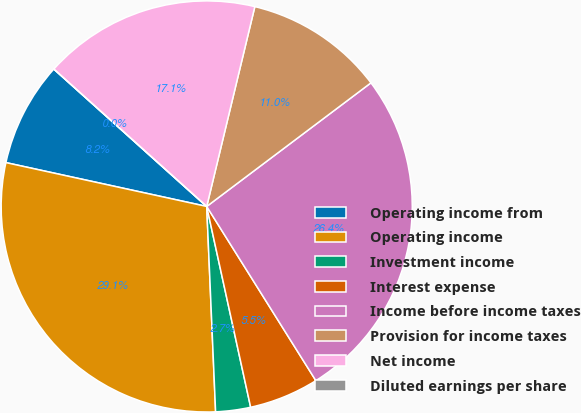Convert chart to OTSL. <chart><loc_0><loc_0><loc_500><loc_500><pie_chart><fcel>Operating income from<fcel>Operating income<fcel>Investment income<fcel>Interest expense<fcel>Income before income taxes<fcel>Provision for income taxes<fcel>Net income<fcel>Diluted earnings per share<nl><fcel>8.23%<fcel>29.11%<fcel>2.74%<fcel>5.48%<fcel>26.36%<fcel>10.97%<fcel>17.11%<fcel>0.0%<nl></chart> 